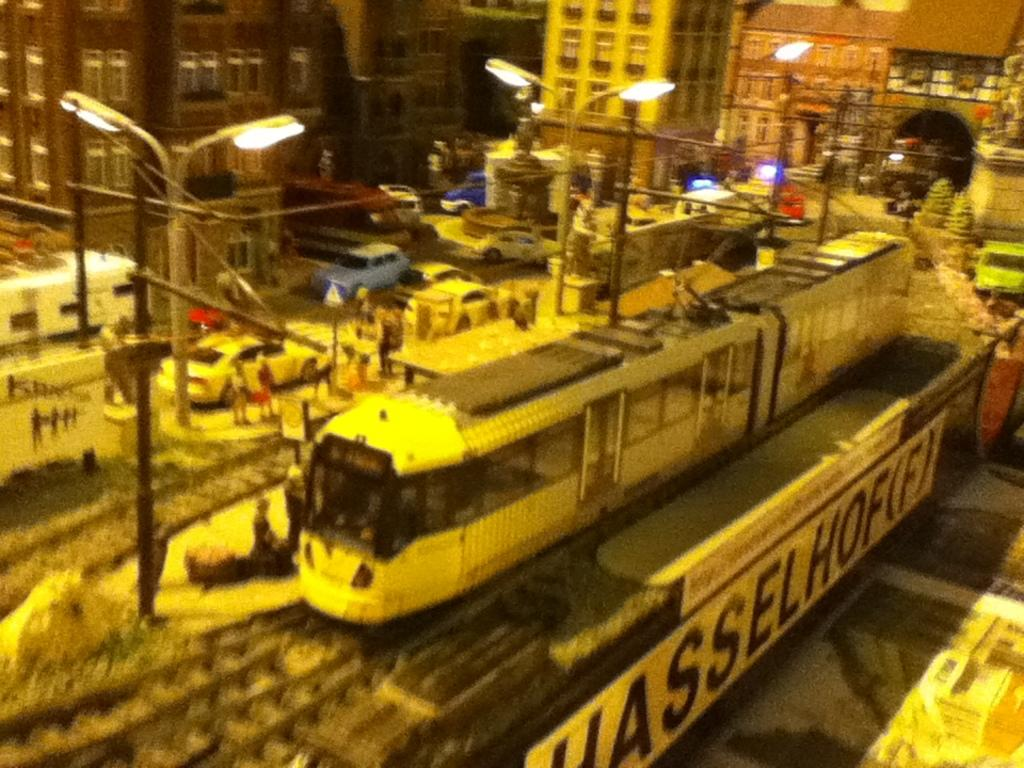<image>
Give a short and clear explanation of the subsequent image. A train pulls into the Hasselhofifi station at night. 